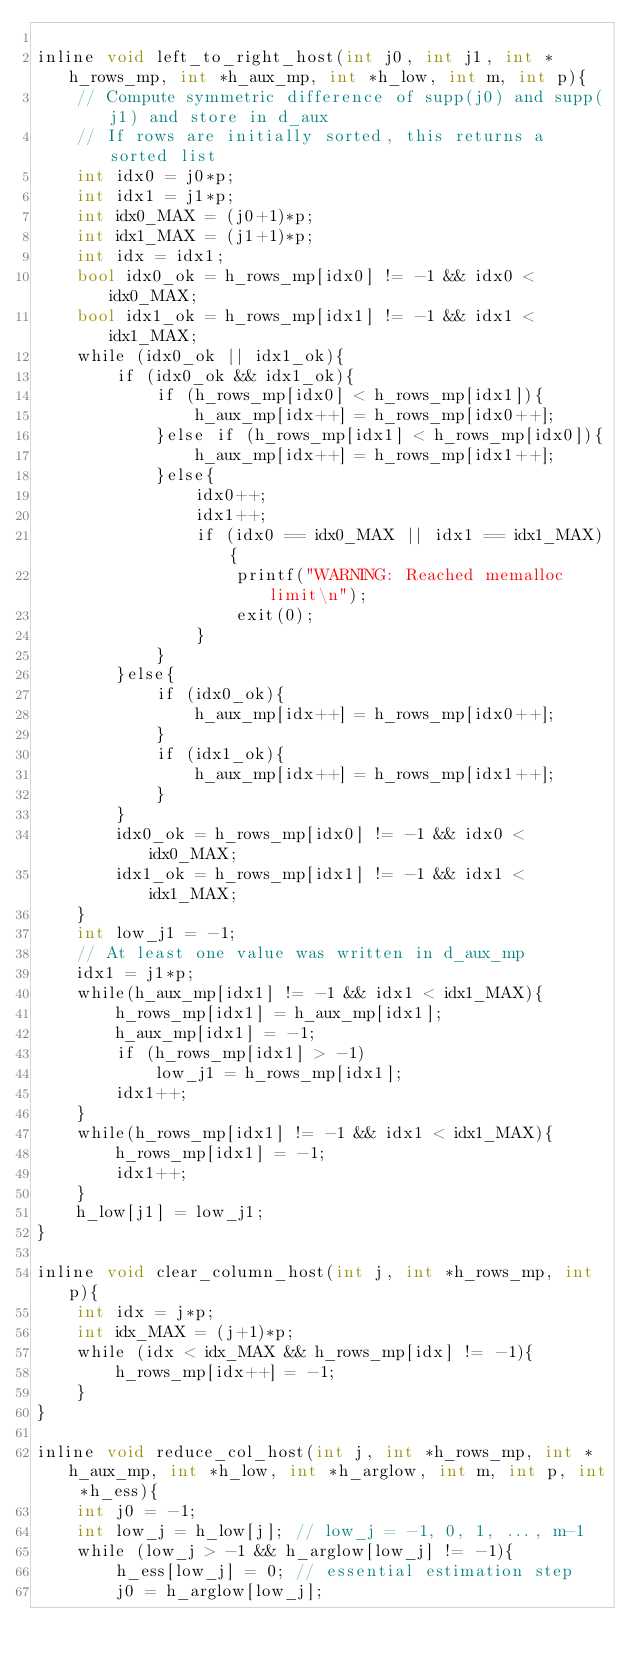Convert code to text. <code><loc_0><loc_0><loc_500><loc_500><_Cuda_>
inline void left_to_right_host(int j0, int j1, int *h_rows_mp, int *h_aux_mp, int *h_low, int m, int p){
    // Compute symmetric difference of supp(j0) and supp(j1) and store in d_aux
    // If rows are initially sorted, this returns a sorted list
    int idx0 = j0*p; 
    int idx1 = j1*p; 
    int idx0_MAX = (j0+1)*p; 
    int idx1_MAX = (j1+1)*p; 
    int idx = idx1;
    bool idx0_ok = h_rows_mp[idx0] != -1 && idx0 < idx0_MAX;
    bool idx1_ok = h_rows_mp[idx1] != -1 && idx1 < idx1_MAX;
    while (idx0_ok || idx1_ok){
        if (idx0_ok && idx1_ok){
            if (h_rows_mp[idx0] < h_rows_mp[idx1]){
                h_aux_mp[idx++] = h_rows_mp[idx0++];
            }else if (h_rows_mp[idx1] < h_rows_mp[idx0]){
                h_aux_mp[idx++] = h_rows_mp[idx1++];
            }else{
                idx0++;
                idx1++;
                if (idx0 == idx0_MAX || idx1 == idx1_MAX){
                    printf("WARNING: Reached memalloc limit\n");
                    exit(0);
                }
            }
        }else{
            if (idx0_ok){
                h_aux_mp[idx++] = h_rows_mp[idx0++];
            }
            if (idx1_ok){
                h_aux_mp[idx++] = h_rows_mp[idx1++];
            }
        }
        idx0_ok = h_rows_mp[idx0] != -1 && idx0 < idx0_MAX;
        idx1_ok = h_rows_mp[idx1] != -1 && idx1 < idx1_MAX;
    }
    int low_j1 = -1;
    // At least one value was written in d_aux_mp
    idx1 = j1*p;
    while(h_aux_mp[idx1] != -1 && idx1 < idx1_MAX){
        h_rows_mp[idx1] = h_aux_mp[idx1];
        h_aux_mp[idx1] = -1;
        if (h_rows_mp[idx1] > -1)
            low_j1 = h_rows_mp[idx1];
        idx1++;
    }
    while(h_rows_mp[idx1] != -1 && idx1 < idx1_MAX){
        h_rows_mp[idx1] = -1;
        idx1++;
    }
    h_low[j1] = low_j1;
}

inline void clear_column_host(int j, int *h_rows_mp, int p){
    int idx = j*p; 
    int idx_MAX = (j+1)*p; 
    while (idx < idx_MAX && h_rows_mp[idx] != -1){
        h_rows_mp[idx++] = -1;
    }
}

inline void reduce_col_host(int j, int *h_rows_mp, int *h_aux_mp, int *h_low, int *h_arglow, int m, int p, int *h_ess){
    int j0 = -1;
    int low_j = h_low[j]; // low_j = -1, 0, 1, ..., m-1
    while (low_j > -1 && h_arglow[low_j] != -1){
        h_ess[low_j] = 0; // essential estimation step
        j0 = h_arglow[low_j];</code> 